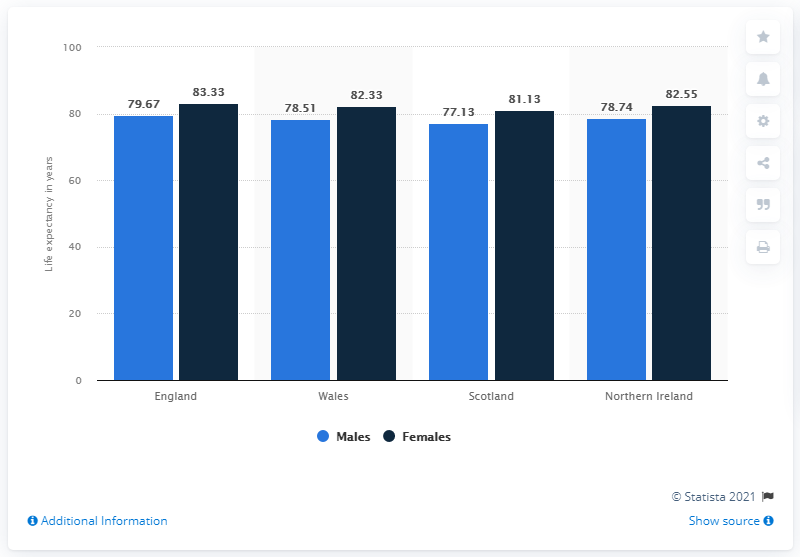Outline some significant characteristics in this image. In 2019, the average life expectancy at birth in Scotland was 77.13 years. In Scotland in 2019, the life expectancy for females at birth was 81.13 years. The life expectancy at birth for males in England in 2019 was 79.67 years. 